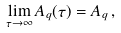Convert formula to latex. <formula><loc_0><loc_0><loc_500><loc_500>\lim _ { \tau \to \infty } A _ { q } ( \tau ) = A _ { q } \, ,</formula> 